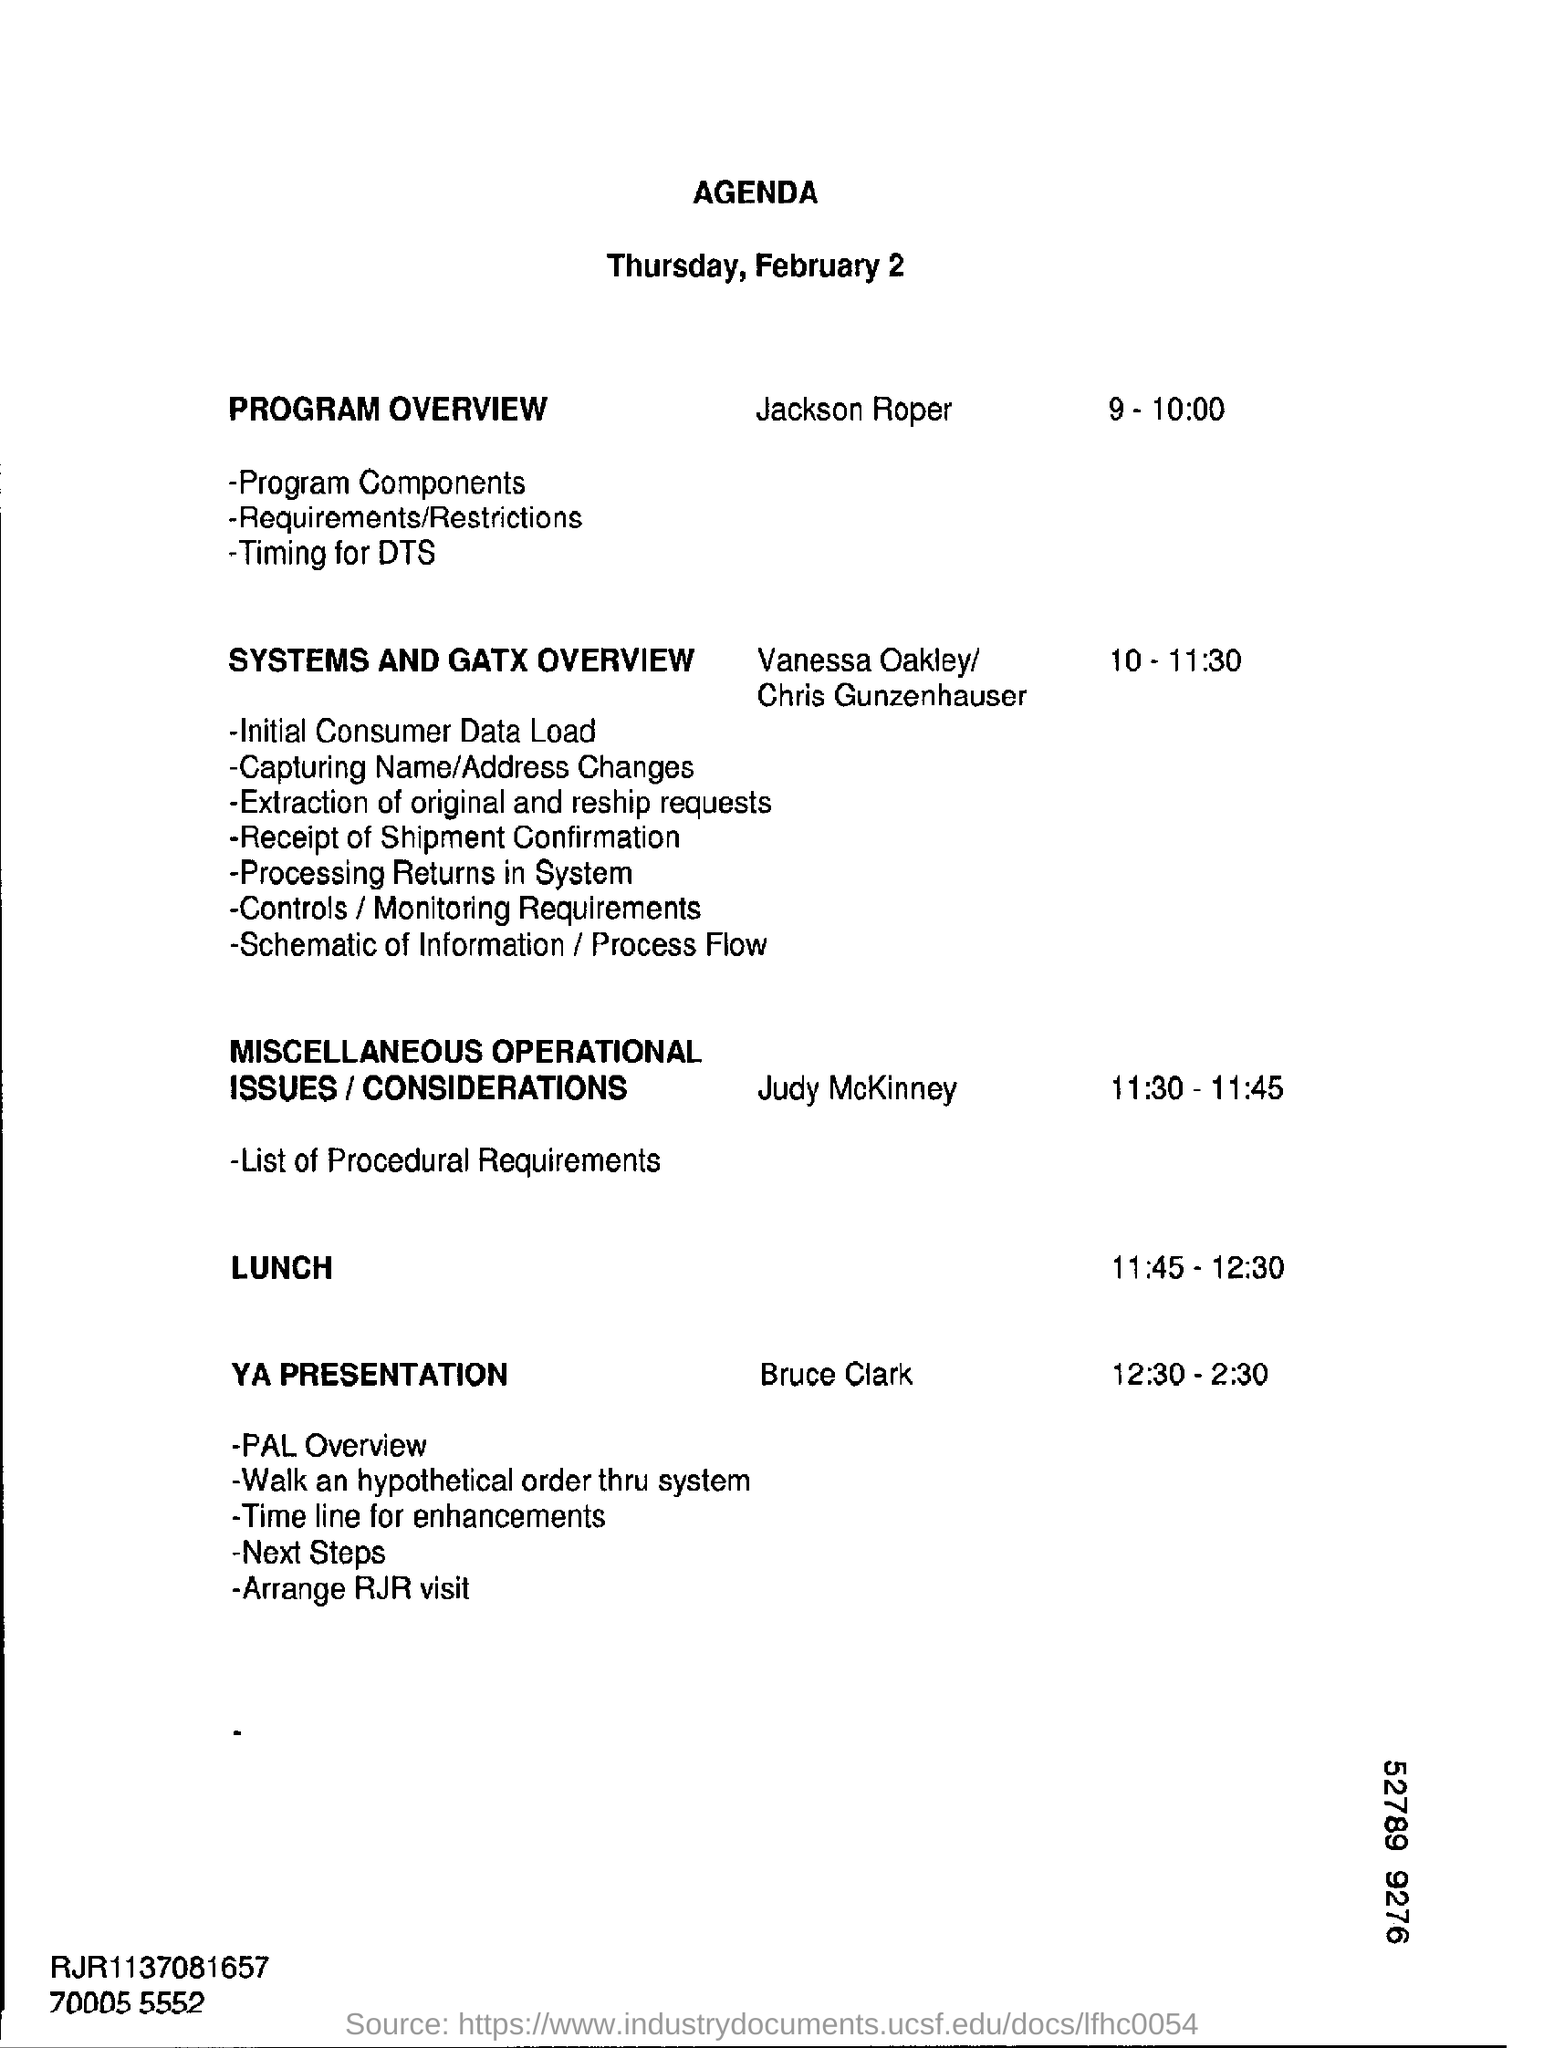Who is presenting the program overview?
Your answer should be compact. Jackson Roper. What is the lunch time as per the agenda?
Your answer should be very brief. 11:45 - 12:30. What is the YA presentation timing?
Ensure brevity in your answer.  12:30 - 2:30. At what time is Systems and Gatx Overview scheduled?
Keep it short and to the point. 10 - 11:30. 